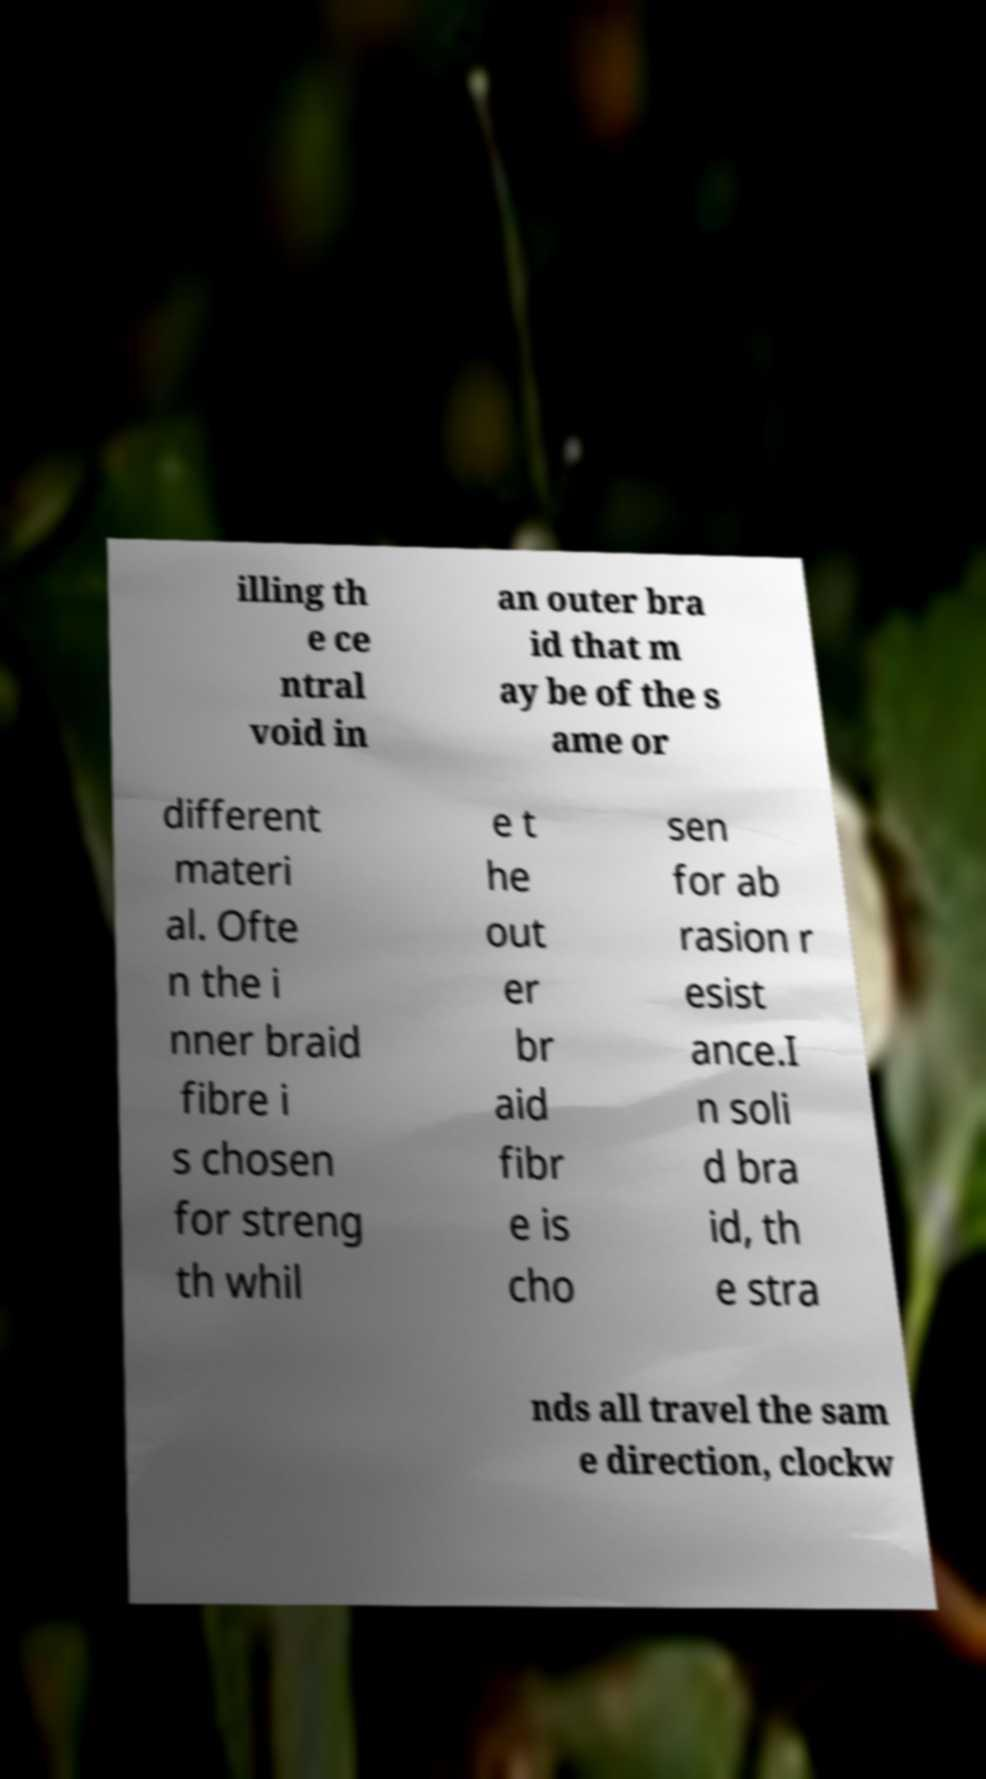Can you accurately transcribe the text from the provided image for me? illing th e ce ntral void in an outer bra id that m ay be of the s ame or different materi al. Ofte n the i nner braid fibre i s chosen for streng th whil e t he out er br aid fibr e is cho sen for ab rasion r esist ance.I n soli d bra id, th e stra nds all travel the sam e direction, clockw 